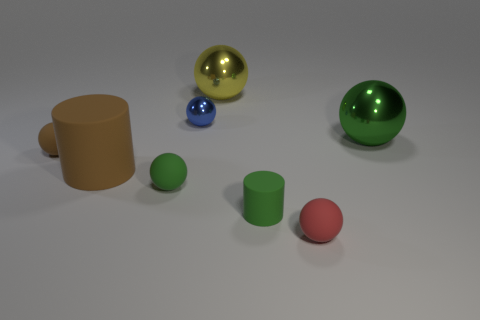What number of objects are both in front of the brown rubber ball and behind the big green ball?
Your answer should be very brief. 0. Is there any other thing that has the same shape as the red rubber object?
Provide a succinct answer. Yes. What number of other objects are there of the same size as the yellow ball?
Offer a terse response. 2. Do the green matte object left of the tiny rubber cylinder and the cylinder left of the small blue shiny thing have the same size?
Your answer should be compact. No. How many objects are gray metallic cylinders or rubber cylinders that are on the left side of the green rubber cylinder?
Provide a short and direct response. 1. How big is the rubber ball to the right of the tiny metal ball?
Make the answer very short. Small. Is the number of brown rubber things to the left of the big rubber cylinder less than the number of large brown cylinders on the right side of the small green cylinder?
Offer a terse response. No. What is the tiny sphere that is both to the left of the blue object and behind the large brown rubber thing made of?
Your answer should be very brief. Rubber. What shape is the big thing in front of the shiny sphere to the right of the big yellow object?
Ensure brevity in your answer.  Cylinder. Do the large cylinder and the small metallic sphere have the same color?
Keep it short and to the point. No. 